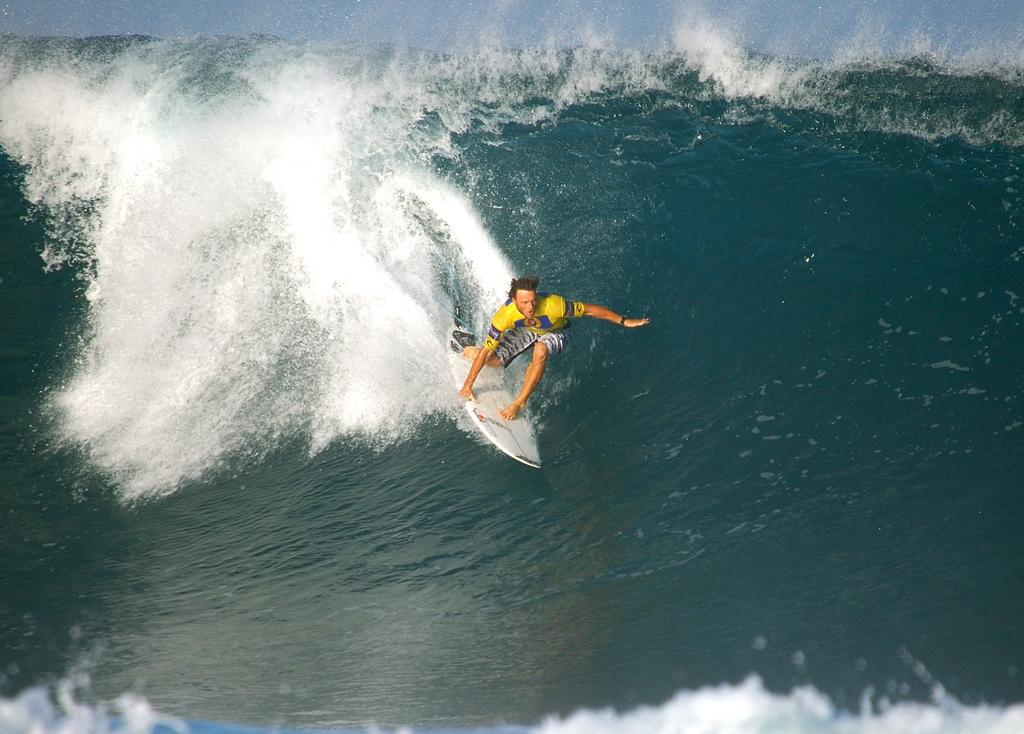What is the main subject of the image? There is a person in the image. What is the person doing in the image? The person is surfing in the water. What part of the natural environment is visible in the image? The sky is visible in the image. How many snails can be seen crawling on the frame of the image? There are no snails present in the image, and there is no frame mentioned in the facts provided. 